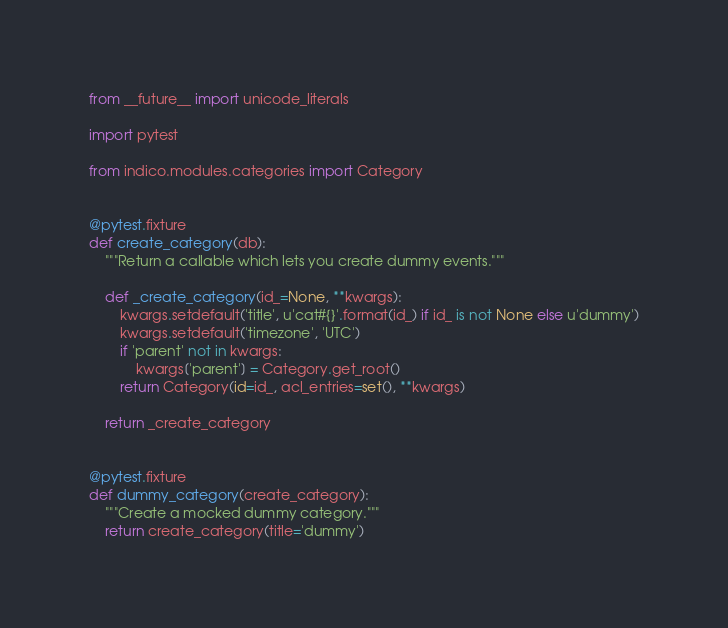Convert code to text. <code><loc_0><loc_0><loc_500><loc_500><_Python_>from __future__ import unicode_literals

import pytest

from indico.modules.categories import Category


@pytest.fixture
def create_category(db):
    """Return a callable which lets you create dummy events."""

    def _create_category(id_=None, **kwargs):
        kwargs.setdefault('title', u'cat#{}'.format(id_) if id_ is not None else u'dummy')
        kwargs.setdefault('timezone', 'UTC')
        if 'parent' not in kwargs:
            kwargs['parent'] = Category.get_root()
        return Category(id=id_, acl_entries=set(), **kwargs)

    return _create_category


@pytest.fixture
def dummy_category(create_category):
    """Create a mocked dummy category."""
    return create_category(title='dummy')
</code> 